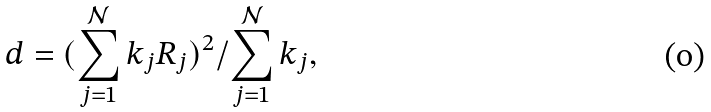<formula> <loc_0><loc_0><loc_500><loc_500>d = ( \sum ^ { \mathcal { N } } _ { j = 1 } k _ { j } { R } _ { j } ) ^ { 2 } / \sum ^ { \mathcal { N } } _ { j = 1 } k _ { j } ,</formula> 